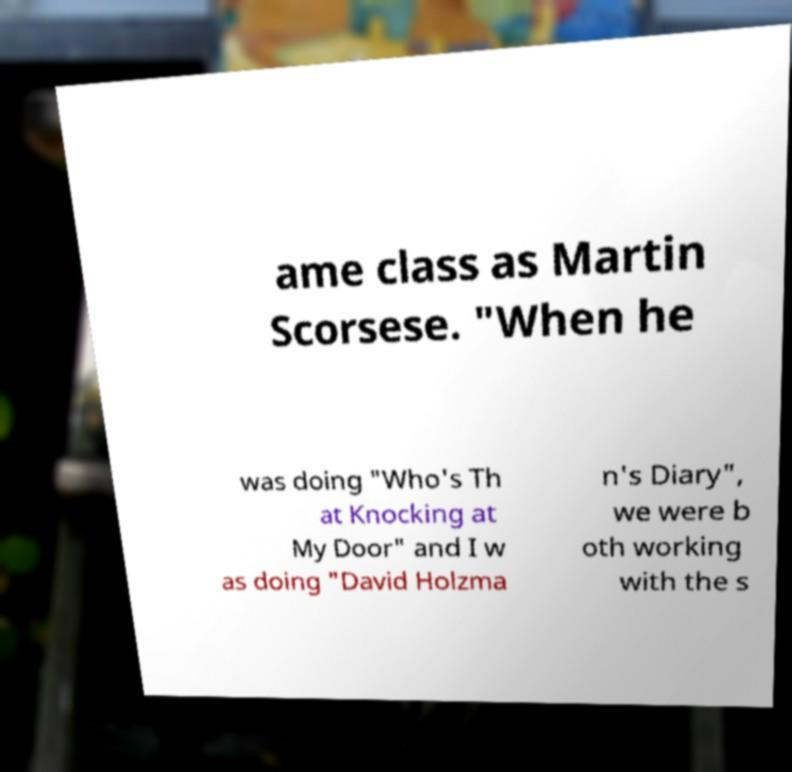Please read and relay the text visible in this image. What does it say? ame class as Martin Scorsese. "When he was doing "Who's Th at Knocking at My Door" and I w as doing "David Holzma n's Diary", we were b oth working with the s 